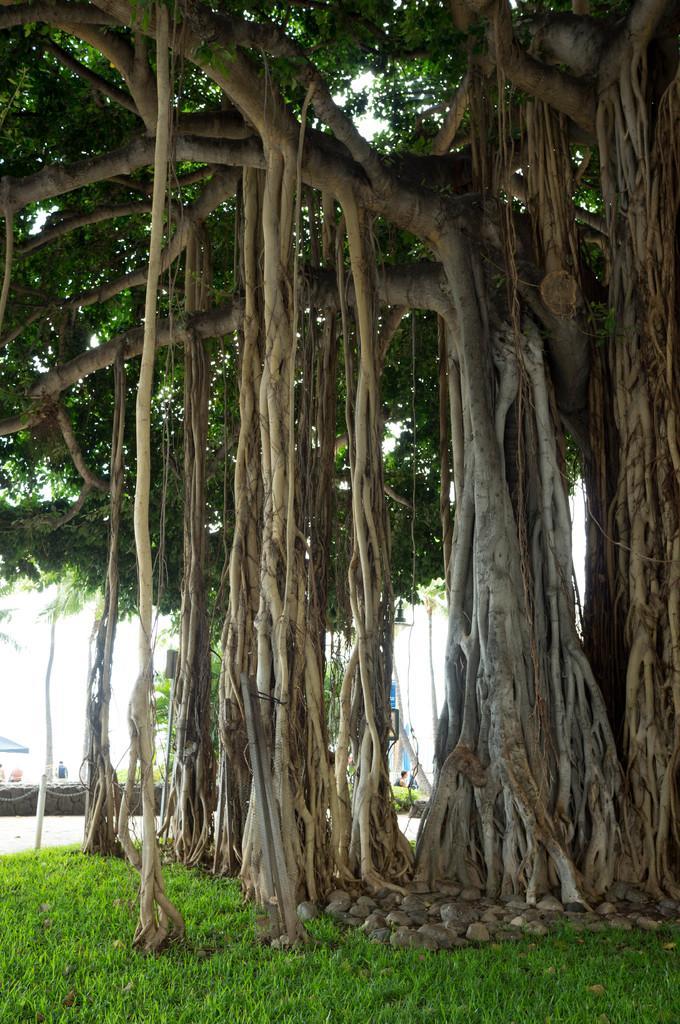Can you describe this image briefly? In the foreground of the picture we can see rocks, grass and a tree. In the background towards left there are plants, people and other objects. In the background there is sky. 